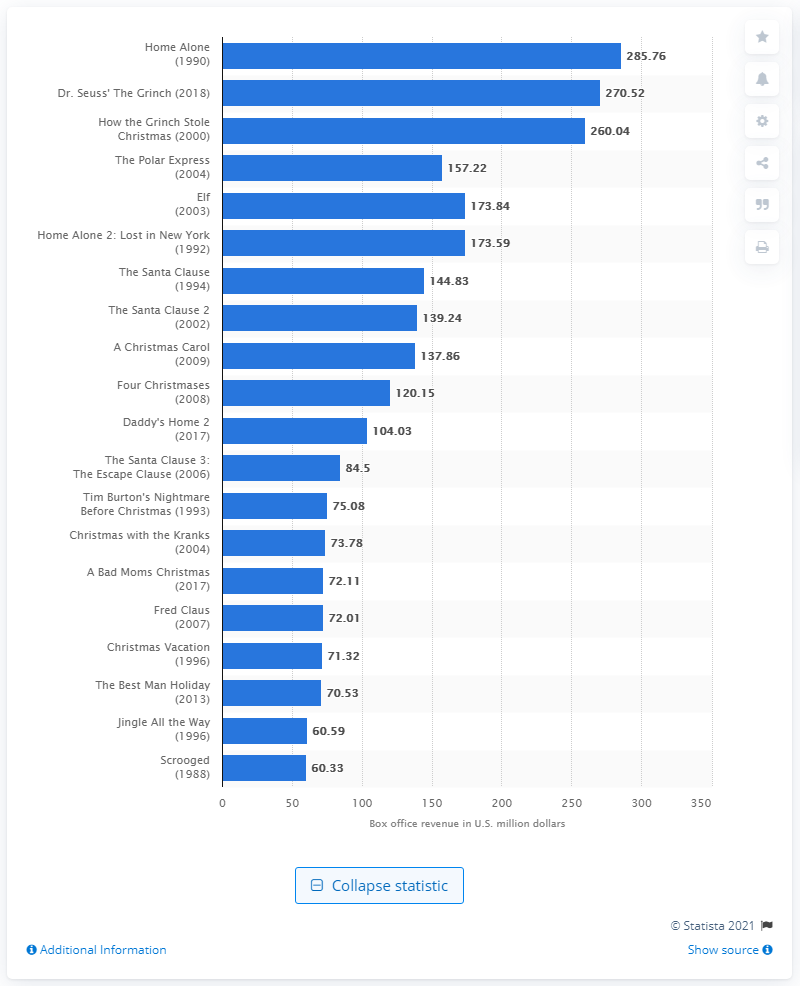Specify some key components in this picture. The Grinch earned a domestic box office total of $270.52 at the box office. The film 'Home Alone' made a total of 285.76 million dollars throughout its lifetime. 